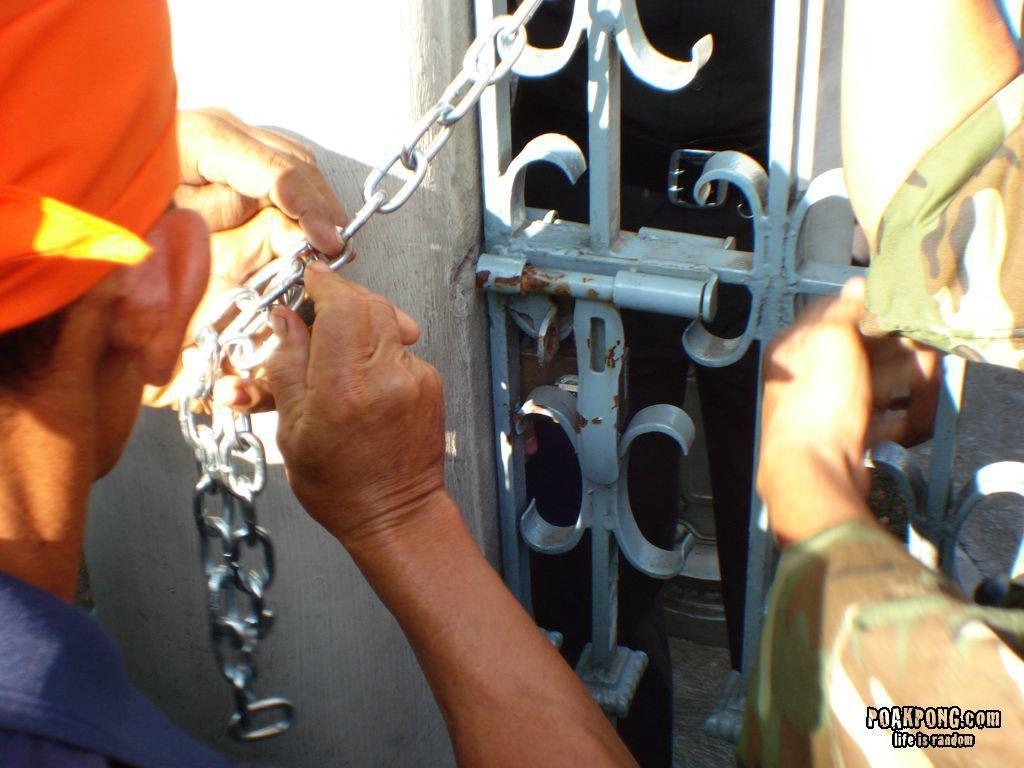How many people are in the image? There are two people in the image. What are the people doing in the image? The people are doing some work. What is in front of the people? There is a gate, a steel chain, and a wall in front of the people. What type of advertisement can be seen on the wall in the image? There is no advertisement visible on the wall in the image. What is the drain used for in the image? There is no drain present in the image. 